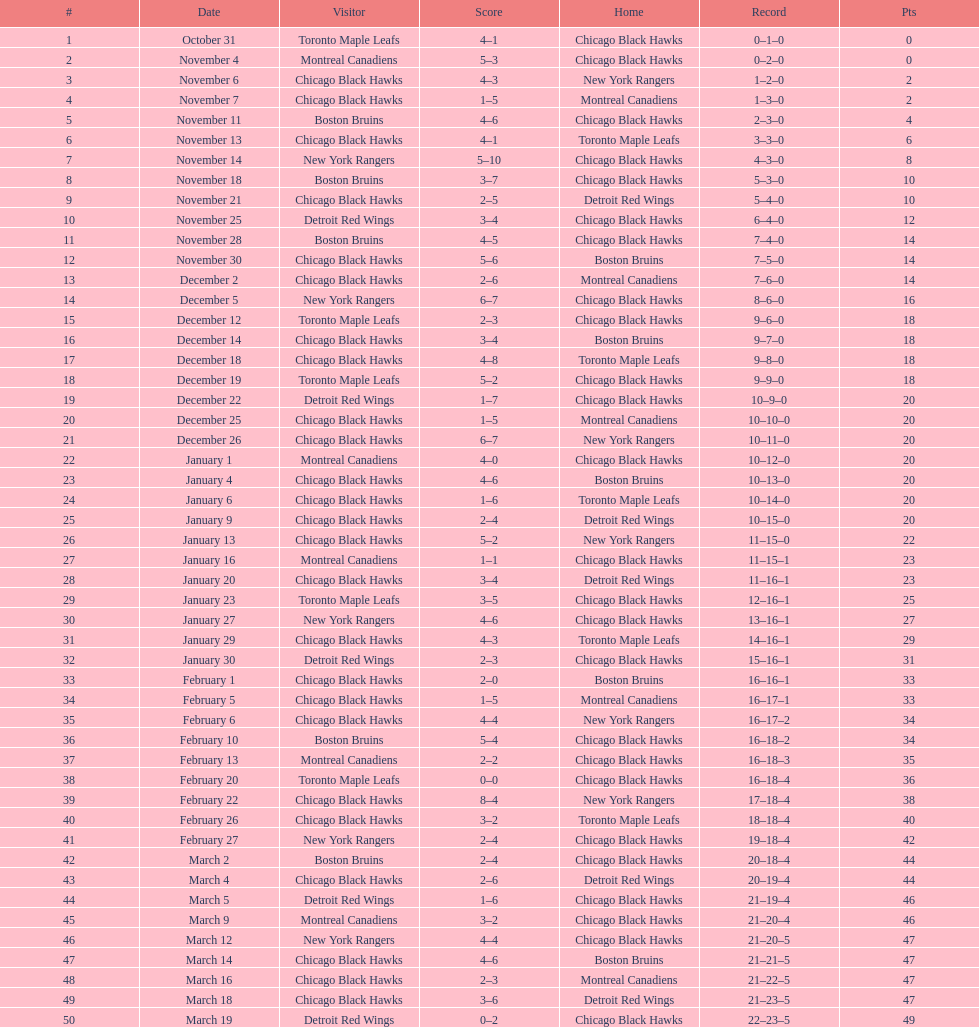Which team was the first one the black hawks lost to? Toronto Maple Leafs. 